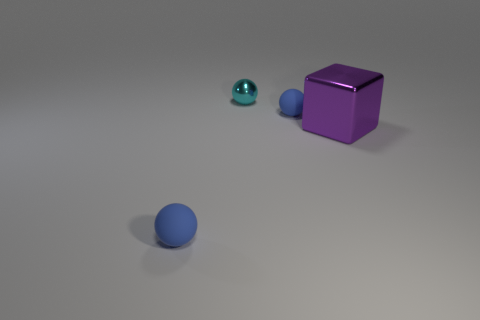Add 2 red cylinders. How many objects exist? 6 Subtract all blocks. How many objects are left? 3 Subtract 0 green cylinders. How many objects are left? 4 Subtract all big purple metal cubes. Subtract all cyan shiny spheres. How many objects are left? 2 Add 2 small balls. How many small balls are left? 5 Add 4 tiny matte objects. How many tiny matte objects exist? 6 